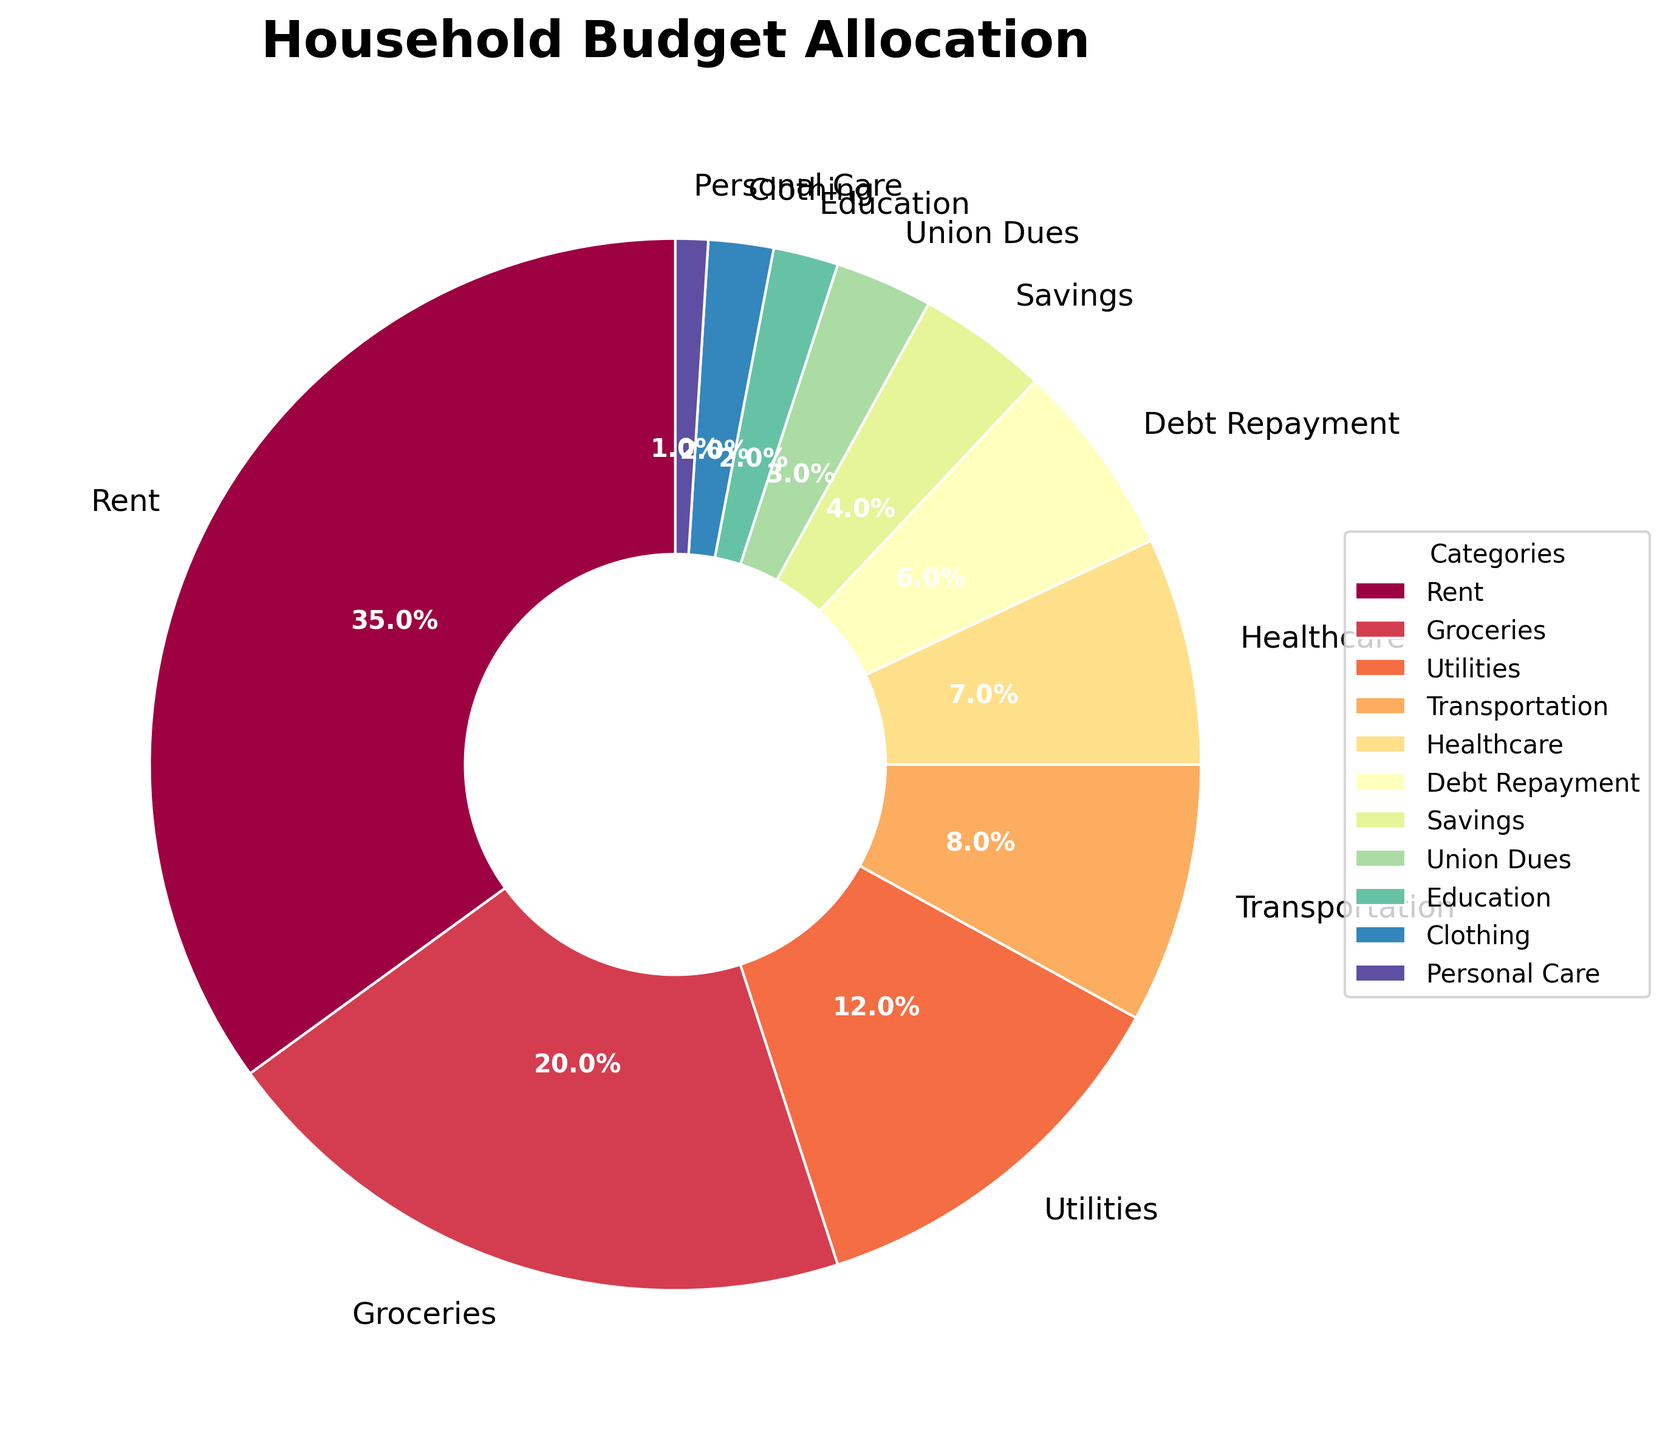What is the largest category in the household budget allocation? The largest category can be determined by the percentage value assigned to each category in the pie chart. Rent has the highest percentage at 35%.
Answer: Rent What is the combined percentage of Groceries and Utilities in the household budget? Adding the percentages for Groceries (20%) and Utilities (12%): 20% + 12% = 32%.
Answer: 32% How does the percentage allocated to Transportation compare with Healthcare? The percentage for Transportation is 8%, and for Healthcare, it is 7%. Transportation has a higher percentage than Healthcare.
Answer: Transportation > Healthcare Which category has the smallest allocation in the household budget? By examining the pie chart, Personal Care has the smallest allocation at 1%.
Answer: Personal Care Which two categories together make up the same percentage as Rent? Rent is 35%. Combining Groceries (20%) and Utilities (12%) gives a total of 32%, which is still less than Rent. Adding Transportation (8%) and Healthcare (7%) gives 15%, also less. But combining Debt Repayment (6%) and Healthcare (7%) gives 13%, yielding 32%. Adding one more small category such as Union Dues (3%) gives a precise 35%. Thus, combining Groceries and Utilities (20% + 12%) plus Clothing (2%) and Personal Care (1%) gives the exact 35%.
Answer: Groceries + Utilities + Clothing + Personal Care What is the difference in percentage points between Rent and Debt Repayment? Rent is 35% and Debt Repayment is 6%. The difference is 35% - 6% = 29%.
Answer: 29% Which category with the smallest visual wedge on the pie chart, both in terms of angle and size? Personal Care, with only 1%, has the smallest wedge in terms of both angle and size on the pie chart.
Answer: Personal Care If Union Dues and Education percentages were to be summed, would they surpass Transportation's percentage? Union Dues (3%) + Education (2%) = 5%. Transportation is 8%. Summing Union Dues and Education results in 5%, which is less than Transportation's 8%.
Answer: No What is the median value of the categories shown in the chart? The percentages are ordered as: 1, 2, 2, 3, 4, 6, 7, 8, 12, 20, 35. With 11 values, the median is the 6th value in the ordered list. The 6th value is Debt Repayment at 6%.
Answer: 6% Is the total percentage allocated to Healthcare, Debt Repayment, and Savings more than the Rent category? Healthcare is 7%, Debt Repayment is 6%, and Savings is 4%. Their combined total is 7% + 6% + 4% = 17%. Rent is 35%. The total for Healthcare, Debt Repayment, and Savings is less than Rent.
Answer: No 